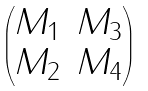<formula> <loc_0><loc_0><loc_500><loc_500>\begin{pmatrix} M _ { 1 } & M _ { 3 } \\ M _ { 2 } & M _ { 4 } \end{pmatrix}</formula> 